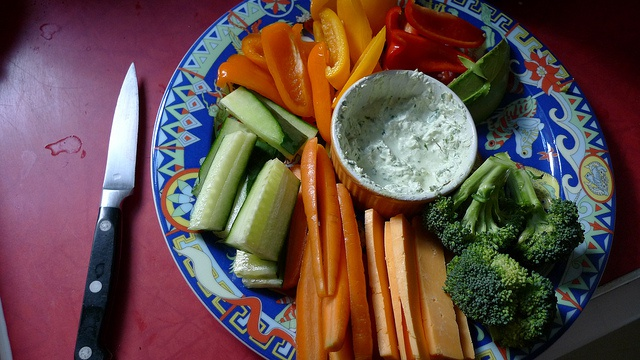Describe the objects in this image and their specific colors. I can see dining table in black, gray, maroon, and purple tones, broccoli in black and darkgreen tones, bowl in black, gray, darkgray, and lightblue tones, carrot in black, brown, maroon, and tan tones, and knife in black, white, navy, and lavender tones in this image. 